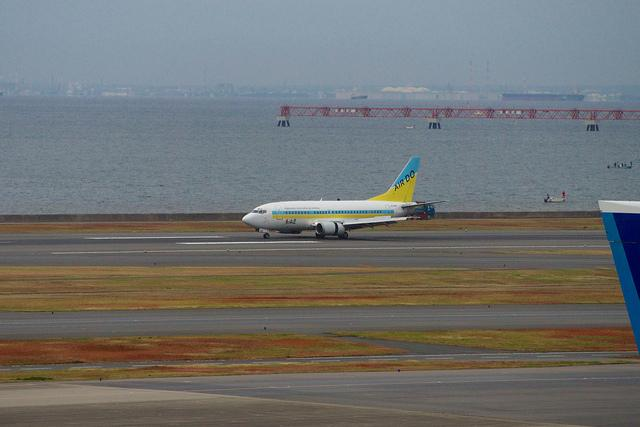The colors of this vehicle resemble which flag?

Choices:
A) belarus
B) russia
C) argentina
D) india argentina 